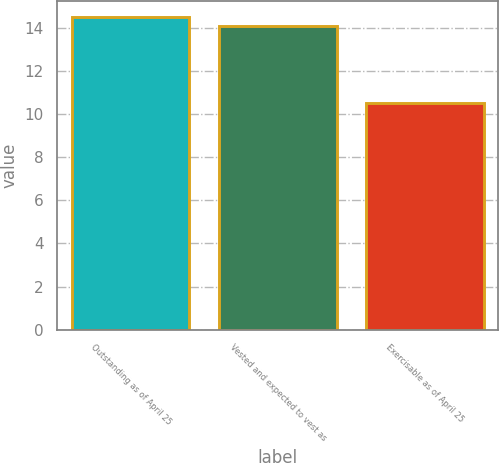<chart> <loc_0><loc_0><loc_500><loc_500><bar_chart><fcel>Outstanding as of April 25<fcel>Vested and expected to vest as<fcel>Exercisable as of April 25<nl><fcel>14.5<fcel>14.1<fcel>10.5<nl></chart> 